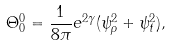Convert formula to latex. <formula><loc_0><loc_0><loc_500><loc_500>\Theta _ { 0 } ^ { 0 } = \frac { 1 } { 8 \pi } e ^ { 2 \gamma } ( \psi _ { \rho } ^ { 2 } + \psi _ { t } ^ { 2 } ) ,</formula> 